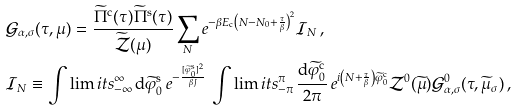<formula> <loc_0><loc_0><loc_500><loc_500>& \mathcal { G } _ { \alpha , \sigma } ( \tau , \mu ) = \frac { \widetilde { \Pi } ^ { \text  c} (\tau)\widetilde{\Pi}^{\text  s} (\tau)} {\widetilde{\mathcal{Z} } ( \mu ) } \sum _ { N } e ^ { - \beta E _ { \text {c} } \left ( N - N _ { 0 } + \frac { \tau } { \beta } \right ) ^ { 2 } } \mathcal { I } _ { N } \, , \\ & \mathcal { I } _ { N } \equiv \int \lim i t s _ { - \infty } ^ { \infty } \, \mathrm d \widetilde { \varphi } ^ { \text  s}_{0}\, e^{-\frac{[\widetilde{\varphi}^{\text  s}_{0}]^{2}} { \beta J } } \, \int \lim i t s _ { - \pi } ^ { \pi } \, \frac { \mathrm d \widetilde { \varphi } ^ { \text  c}_{0}}{2\pi}\, e^{{i}\left(N+\frac{\tau}{\beta}\right) \widetilde{\varphi}^{\text  c}_{0}}\mathcal{Z}^{0} (\widetilde{\mu}) \mathcal{G}^{0}_{\alpha,\sigma}(\tau,\widetilde{\mu}_{\sigma})\,,</formula> 